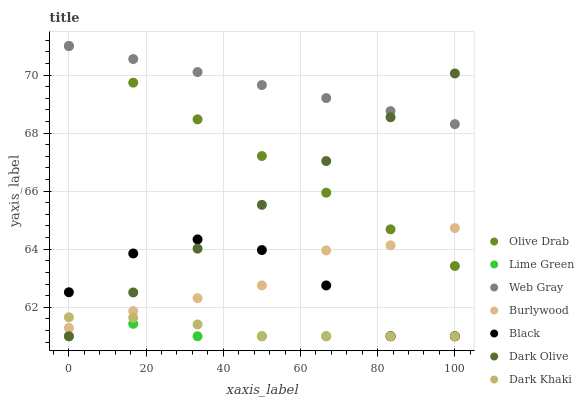Does Lime Green have the minimum area under the curve?
Answer yes or no. Yes. Does Web Gray have the maximum area under the curve?
Answer yes or no. Yes. Does Burlywood have the minimum area under the curve?
Answer yes or no. No. Does Burlywood have the maximum area under the curve?
Answer yes or no. No. Is Dark Olive the smoothest?
Answer yes or no. Yes. Is Black the roughest?
Answer yes or no. Yes. Is Burlywood the smoothest?
Answer yes or no. No. Is Burlywood the roughest?
Answer yes or no. No. Does Dark Olive have the lowest value?
Answer yes or no. Yes. Does Burlywood have the lowest value?
Answer yes or no. No. Does Olive Drab have the highest value?
Answer yes or no. Yes. Does Burlywood have the highest value?
Answer yes or no. No. Is Burlywood less than Web Gray?
Answer yes or no. Yes. Is Web Gray greater than Lime Green?
Answer yes or no. Yes. Does Dark Khaki intersect Lime Green?
Answer yes or no. Yes. Is Dark Khaki less than Lime Green?
Answer yes or no. No. Is Dark Khaki greater than Lime Green?
Answer yes or no. No. Does Burlywood intersect Web Gray?
Answer yes or no. No. 